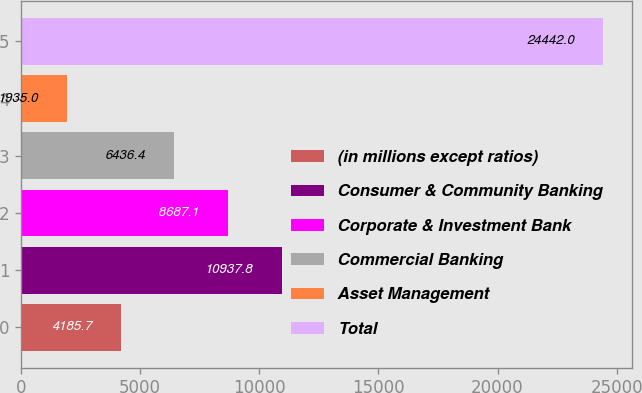<chart> <loc_0><loc_0><loc_500><loc_500><bar_chart><fcel>(in millions except ratios)<fcel>Consumer & Community Banking<fcel>Corporate & Investment Bank<fcel>Commercial Banking<fcel>Asset Management<fcel>Total<nl><fcel>4185.7<fcel>10937.8<fcel>8687.1<fcel>6436.4<fcel>1935<fcel>24442<nl></chart> 